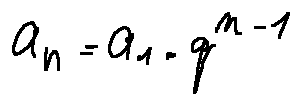<formula> <loc_0><loc_0><loc_500><loc_500>a _ { n } = a _ { 1 } \cdot q ^ { n - 1 }</formula> 